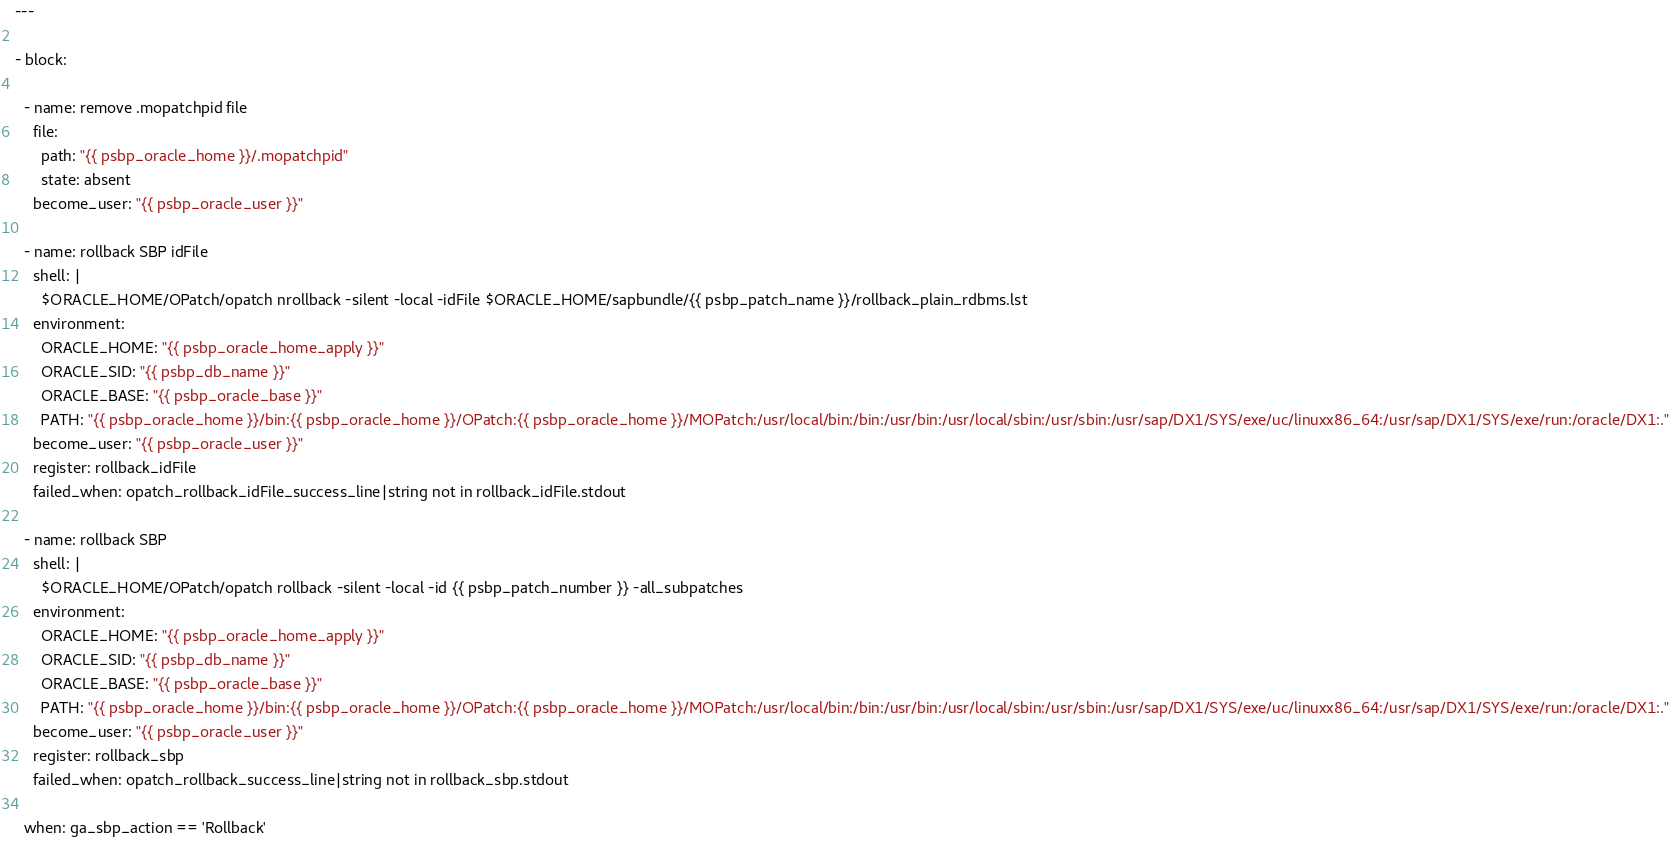<code> <loc_0><loc_0><loc_500><loc_500><_YAML_>---

- block:

  - name: remove .mopatchpid file
    file:
      path: "{{ psbp_oracle_home }}/.mopatchpid"
      state: absent
    become_user: "{{ psbp_oracle_user }}"

  - name: rollback SBP idFile
    shell: |
      $ORACLE_HOME/OPatch/opatch nrollback -silent -local -idFile $ORACLE_HOME/sapbundle/{{ psbp_patch_name }}/rollback_plain_rdbms.lst
    environment:
      ORACLE_HOME: "{{ psbp_oracle_home_apply }}"
      ORACLE_SID: "{{ psbp_db_name }}"
      ORACLE_BASE: "{{ psbp_oracle_base }}"
      PATH: "{{ psbp_oracle_home }}/bin:{{ psbp_oracle_home }}/OPatch:{{ psbp_oracle_home }}/MOPatch:/usr/local/bin:/bin:/usr/bin:/usr/local/sbin:/usr/sbin:/usr/sap/DX1/SYS/exe/uc/linuxx86_64:/usr/sap/DX1/SYS/exe/run:/oracle/DX1:."
    become_user: "{{ psbp_oracle_user }}"
    register: rollback_idFile
    failed_when: opatch_rollback_idFile_success_line|string not in rollback_idFile.stdout
  
  - name: rollback SBP
    shell: |
      $ORACLE_HOME/OPatch/opatch rollback -silent -local -id {{ psbp_patch_number }} -all_subpatches
    environment:
      ORACLE_HOME: "{{ psbp_oracle_home_apply }}"
      ORACLE_SID: "{{ psbp_db_name }}"
      ORACLE_BASE: "{{ psbp_oracle_base }}"
      PATH: "{{ psbp_oracle_home }}/bin:{{ psbp_oracle_home }}/OPatch:{{ psbp_oracle_home }}/MOPatch:/usr/local/bin:/bin:/usr/bin:/usr/local/sbin:/usr/sbin:/usr/sap/DX1/SYS/exe/uc/linuxx86_64:/usr/sap/DX1/SYS/exe/run:/oracle/DX1:."
    become_user: "{{ psbp_oracle_user }}"
    register: rollback_sbp
    failed_when: opatch_rollback_success_line|string not in rollback_sbp.stdout

  when: ga_sbp_action == 'Rollback'
</code> 